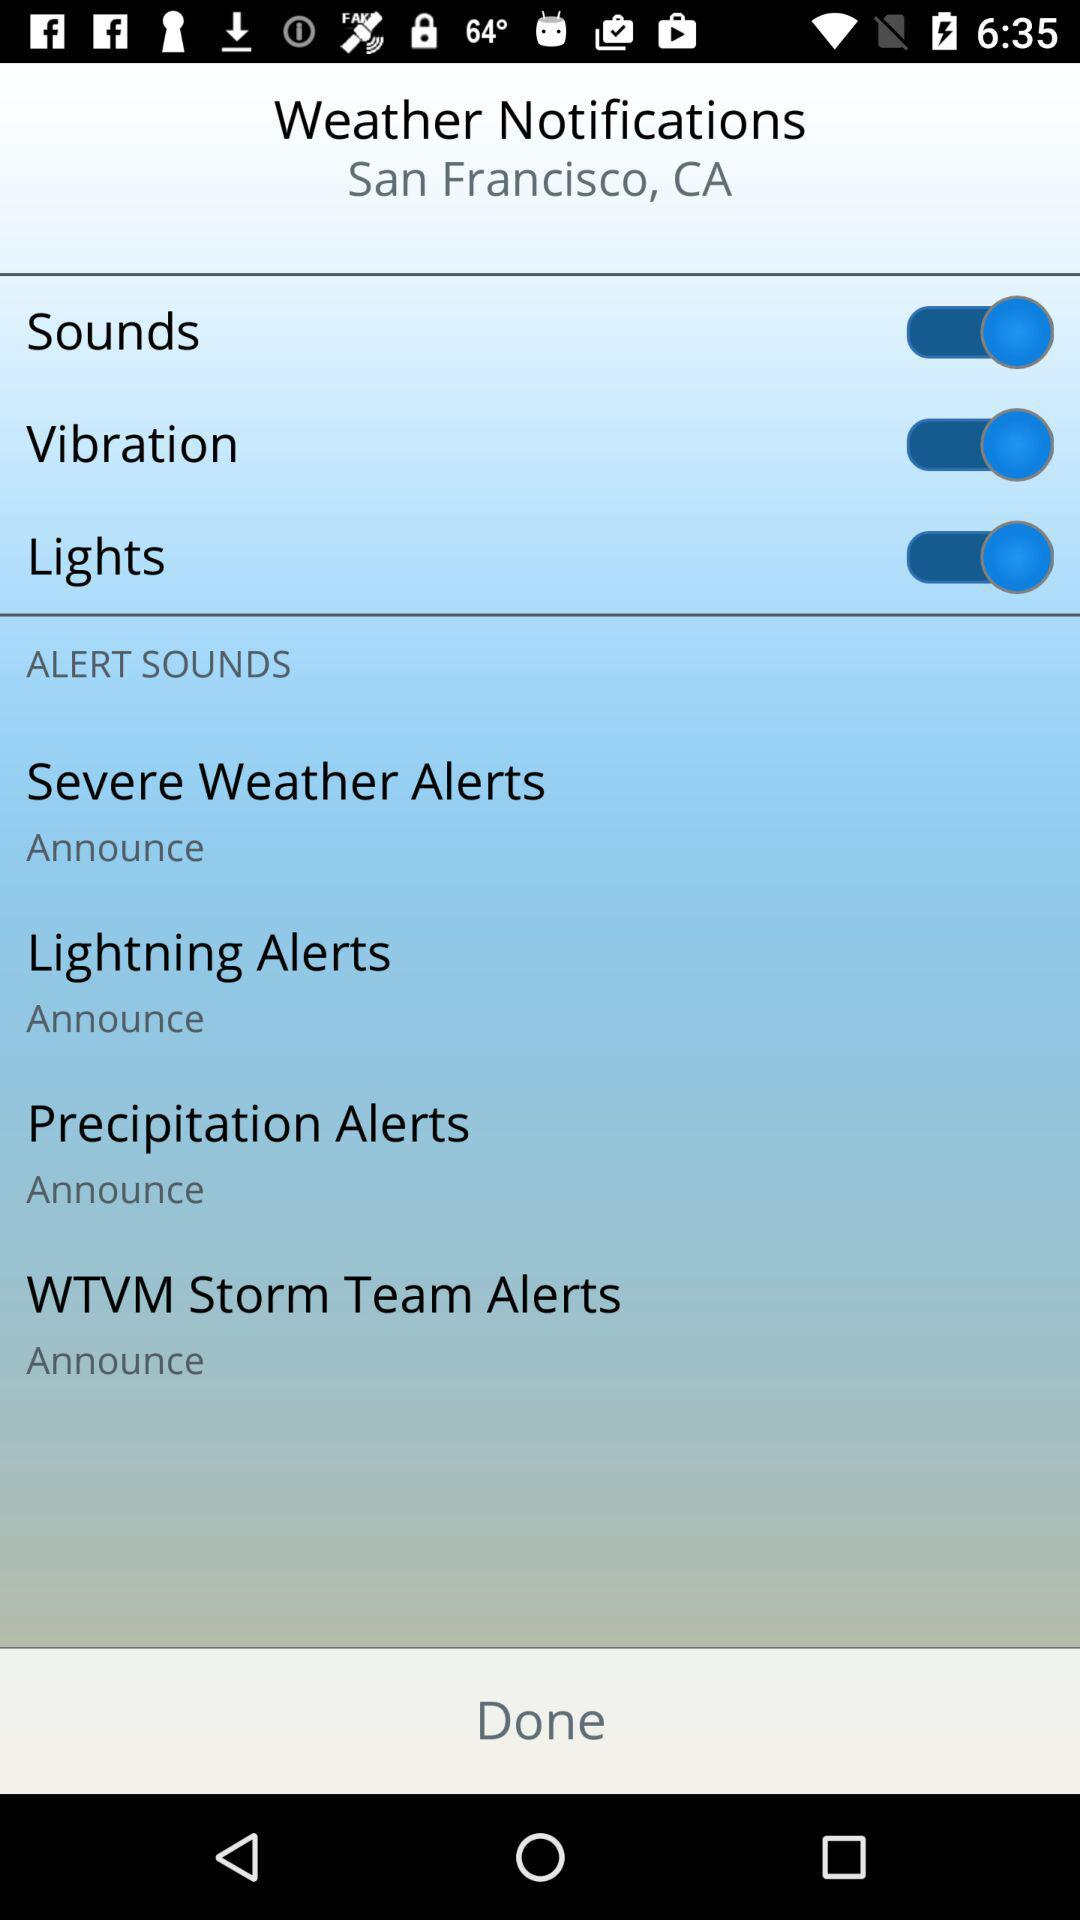How many alert sounds are there?
Answer the question using a single word or phrase. 4 